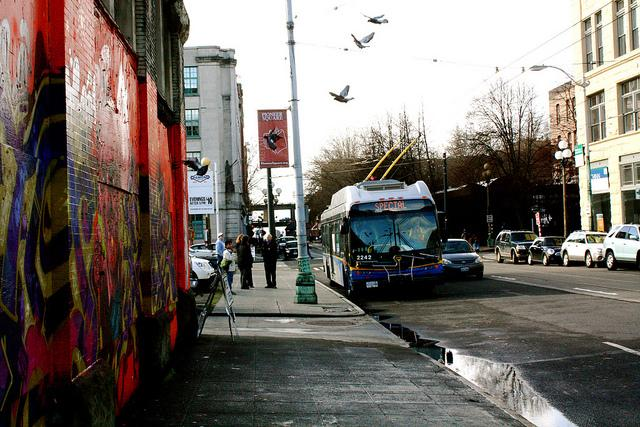What color are the birds flying over the street? Please explain your reasoning. gray. The birds are gray. 